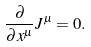Convert formula to latex. <formula><loc_0><loc_0><loc_500><loc_500>\frac { \partial } { \partial x ^ { \mu } } { J } ^ { \mu } = 0 .</formula> 